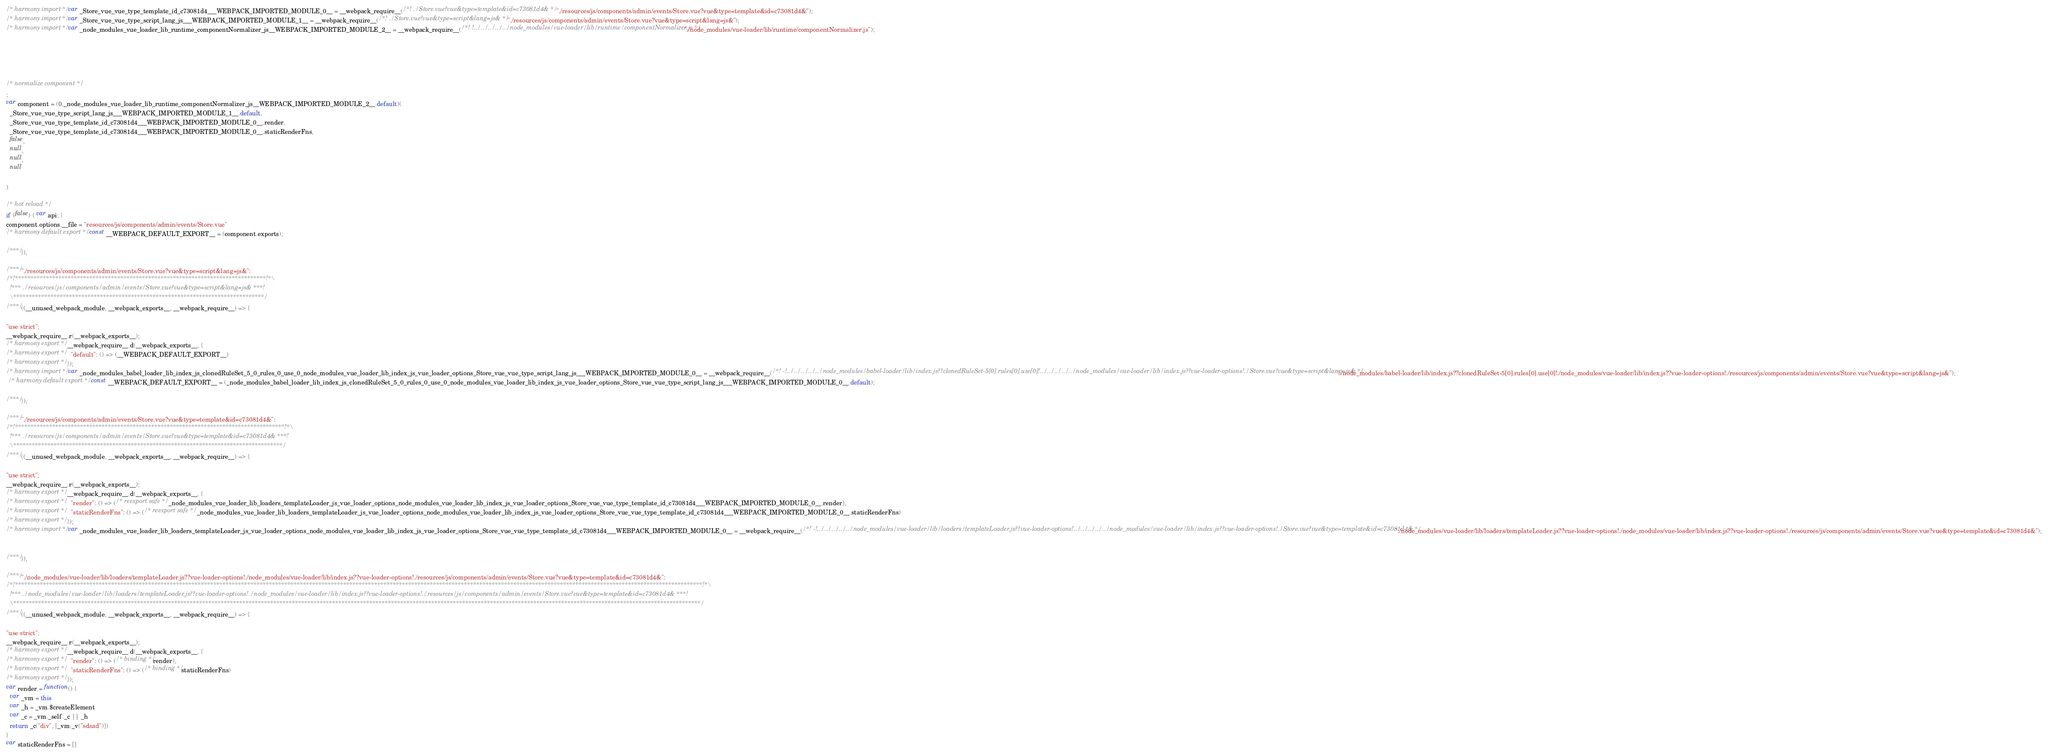<code> <loc_0><loc_0><loc_500><loc_500><_JavaScript_>/* harmony import */ var _Store_vue_vue_type_template_id_c73081d4___WEBPACK_IMPORTED_MODULE_0__ = __webpack_require__(/*! ./Store.vue?vue&type=template&id=c73081d4& */ "./resources/js/components/admin/events/Store.vue?vue&type=template&id=c73081d4&");
/* harmony import */ var _Store_vue_vue_type_script_lang_js___WEBPACK_IMPORTED_MODULE_1__ = __webpack_require__(/*! ./Store.vue?vue&type=script&lang=js& */ "./resources/js/components/admin/events/Store.vue?vue&type=script&lang=js&");
/* harmony import */ var _node_modules_vue_loader_lib_runtime_componentNormalizer_js__WEBPACK_IMPORTED_MODULE_2__ = __webpack_require__(/*! !../../../../../node_modules/vue-loader/lib/runtime/componentNormalizer.js */ "./node_modules/vue-loader/lib/runtime/componentNormalizer.js");





/* normalize component */
;
var component = (0,_node_modules_vue_loader_lib_runtime_componentNormalizer_js__WEBPACK_IMPORTED_MODULE_2__.default)(
  _Store_vue_vue_type_script_lang_js___WEBPACK_IMPORTED_MODULE_1__.default,
  _Store_vue_vue_type_template_id_c73081d4___WEBPACK_IMPORTED_MODULE_0__.render,
  _Store_vue_vue_type_template_id_c73081d4___WEBPACK_IMPORTED_MODULE_0__.staticRenderFns,
  false,
  null,
  null,
  null
  
)

/* hot reload */
if (false) { var api; }
component.options.__file = "resources/js/components/admin/events/Store.vue"
/* harmony default export */ const __WEBPACK_DEFAULT_EXPORT__ = (component.exports);

/***/ }),

/***/ "./resources/js/components/admin/events/Store.vue?vue&type=script&lang=js&":
/*!*********************************************************************************!*\
  !*** ./resources/js/components/admin/events/Store.vue?vue&type=script&lang=js& ***!
  \*********************************************************************************/
/***/ ((__unused_webpack_module, __webpack_exports__, __webpack_require__) => {

"use strict";
__webpack_require__.r(__webpack_exports__);
/* harmony export */ __webpack_require__.d(__webpack_exports__, {
/* harmony export */   "default": () => (__WEBPACK_DEFAULT_EXPORT__)
/* harmony export */ });
/* harmony import */ var _node_modules_babel_loader_lib_index_js_clonedRuleSet_5_0_rules_0_use_0_node_modules_vue_loader_lib_index_js_vue_loader_options_Store_vue_vue_type_script_lang_js___WEBPACK_IMPORTED_MODULE_0__ = __webpack_require__(/*! -!../../../../../node_modules/babel-loader/lib/index.js??clonedRuleSet-5[0].rules[0].use[0]!../../../../../node_modules/vue-loader/lib/index.js??vue-loader-options!./Store.vue?vue&type=script&lang=js& */ "./node_modules/babel-loader/lib/index.js??clonedRuleSet-5[0].rules[0].use[0]!./node_modules/vue-loader/lib/index.js??vue-loader-options!./resources/js/components/admin/events/Store.vue?vue&type=script&lang=js&");
 /* harmony default export */ const __WEBPACK_DEFAULT_EXPORT__ = (_node_modules_babel_loader_lib_index_js_clonedRuleSet_5_0_rules_0_use_0_node_modules_vue_loader_lib_index_js_vue_loader_options_Store_vue_vue_type_script_lang_js___WEBPACK_IMPORTED_MODULE_0__.default); 

/***/ }),

/***/ "./resources/js/components/admin/events/Store.vue?vue&type=template&id=c73081d4&":
/*!***************************************************************************************!*\
  !*** ./resources/js/components/admin/events/Store.vue?vue&type=template&id=c73081d4& ***!
  \***************************************************************************************/
/***/ ((__unused_webpack_module, __webpack_exports__, __webpack_require__) => {

"use strict";
__webpack_require__.r(__webpack_exports__);
/* harmony export */ __webpack_require__.d(__webpack_exports__, {
/* harmony export */   "render": () => (/* reexport safe */ _node_modules_vue_loader_lib_loaders_templateLoader_js_vue_loader_options_node_modules_vue_loader_lib_index_js_vue_loader_options_Store_vue_vue_type_template_id_c73081d4___WEBPACK_IMPORTED_MODULE_0__.render),
/* harmony export */   "staticRenderFns": () => (/* reexport safe */ _node_modules_vue_loader_lib_loaders_templateLoader_js_vue_loader_options_node_modules_vue_loader_lib_index_js_vue_loader_options_Store_vue_vue_type_template_id_c73081d4___WEBPACK_IMPORTED_MODULE_0__.staticRenderFns)
/* harmony export */ });
/* harmony import */ var _node_modules_vue_loader_lib_loaders_templateLoader_js_vue_loader_options_node_modules_vue_loader_lib_index_js_vue_loader_options_Store_vue_vue_type_template_id_c73081d4___WEBPACK_IMPORTED_MODULE_0__ = __webpack_require__(/*! -!../../../../../node_modules/vue-loader/lib/loaders/templateLoader.js??vue-loader-options!../../../../../node_modules/vue-loader/lib/index.js??vue-loader-options!./Store.vue?vue&type=template&id=c73081d4& */ "./node_modules/vue-loader/lib/loaders/templateLoader.js??vue-loader-options!./node_modules/vue-loader/lib/index.js??vue-loader-options!./resources/js/components/admin/events/Store.vue?vue&type=template&id=c73081d4&");


/***/ }),

/***/ "./node_modules/vue-loader/lib/loaders/templateLoader.js??vue-loader-options!./node_modules/vue-loader/lib/index.js??vue-loader-options!./resources/js/components/admin/events/Store.vue?vue&type=template&id=c73081d4&":
/*!******************************************************************************************************************************************************************************************************************************!*\
  !*** ./node_modules/vue-loader/lib/loaders/templateLoader.js??vue-loader-options!./node_modules/vue-loader/lib/index.js??vue-loader-options!./resources/js/components/admin/events/Store.vue?vue&type=template&id=c73081d4& ***!
  \******************************************************************************************************************************************************************************************************************************/
/***/ ((__unused_webpack_module, __webpack_exports__, __webpack_require__) => {

"use strict";
__webpack_require__.r(__webpack_exports__);
/* harmony export */ __webpack_require__.d(__webpack_exports__, {
/* harmony export */   "render": () => (/* binding */ render),
/* harmony export */   "staticRenderFns": () => (/* binding */ staticRenderFns)
/* harmony export */ });
var render = function() {
  var _vm = this
  var _h = _vm.$createElement
  var _c = _vm._self._c || _h
  return _c("div", [_vm._v("sdsad")])
}
var staticRenderFns = []</code> 